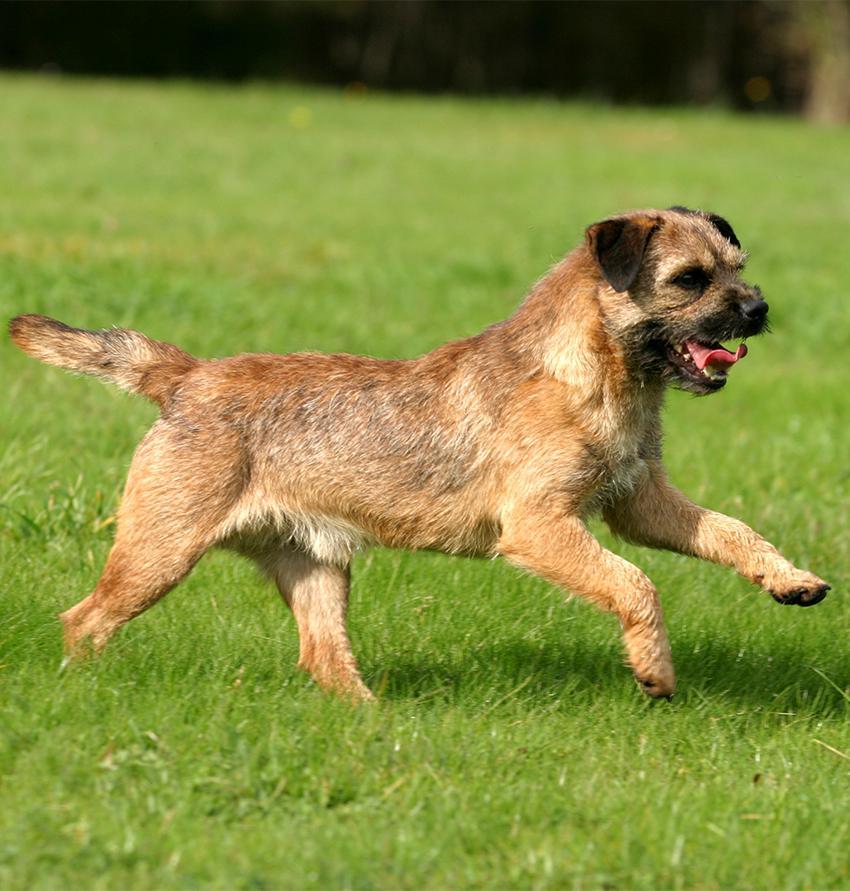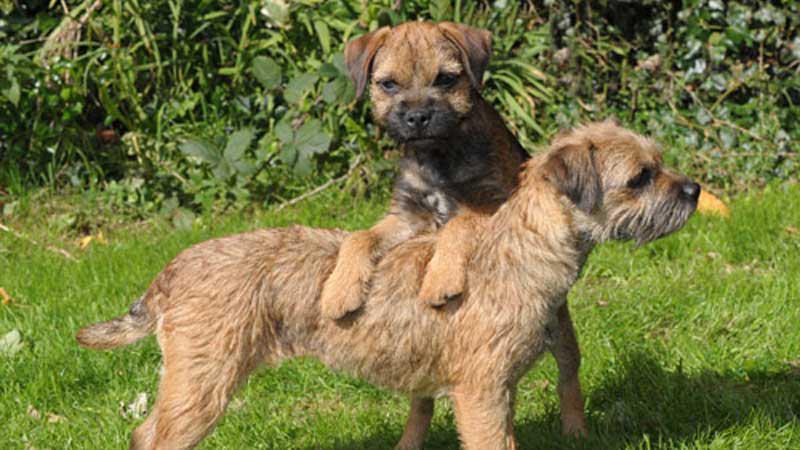The first image is the image on the left, the second image is the image on the right. For the images shown, is this caption "An image shows two dogs together outdoors, and at least one dog is standing with its front paws balanced on something for support." true? Answer yes or no. Yes. The first image is the image on the left, the second image is the image on the right. Analyze the images presented: Is the assertion "The dog in the image on the left is running through the grass." valid? Answer yes or no. Yes. 